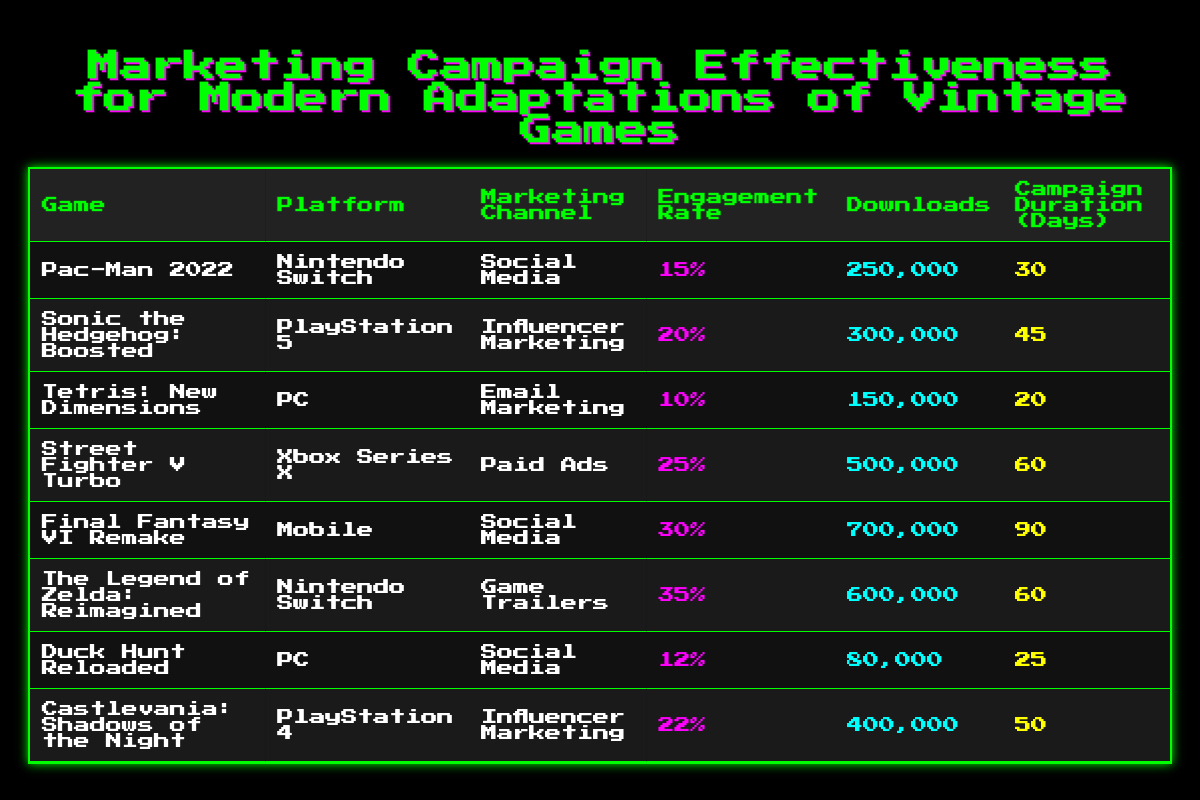What is the platform for "Sonic the Hedgehog: Boosted"? The platform is mentioned in the table directly under the "Platform" column corresponding to "Sonic the Hedgehog: Boosted". The entry shows "PlayStation 5".
Answer: PlayStation 5 Which game had the highest engagement rate? To find this, I look under the "Engagement Rate" column and compare the values. The highest value is 35%, associated with "The Legend of Zelda: Reimagined".
Answer: The Legend of Zelda: Reimagined What is the total number of downloads for games on the Nintendo Switch? I first identify the Nintendo Switch games: "Pac-Man 2022" and "The Legend of Zelda: Reimagined". Next, I sum their downloads: 250,000 + 600,000 = 850,000.
Answer: 850,000 Is the engagement rate for "Tetris: New Dimensions" greater than 15%? The engagement rate for "Tetris: New Dimensions" is 10%, which is lower than 15%. Therefore, the statement is false.
Answer: No How many days of campaign duration did "Final Fantasy VI Remake" have? The "Campaign Duration (Days)" column shows 90 days for "Final Fantasy VI Remake". I directly reference this value.
Answer: 90 days What is the difference in downloads between "Street Fighter V Turbo" and "Duck Hunt Reloaded"? I find the downloads: "Street Fighter V Turbo" has 500,000 downloads, and "Duck Hunt Reloaded" has 80,000 downloads. I calculate the difference: 500,000 - 80,000 = 420,000.
Answer: 420,000 Which marketing channel yielded the most downloads? I examine each game and its downloads, matching them with their respective marketing channels. "Final Fantasy VI Remake," with 700,000 downloads using Social Media, is the highest.
Answer: Social Media What percentage of the total downloads came from "Influencer Marketing"? I identify the total downloads for the two Influencer Marketing games: "Sonic the Hedgehog: Boosted" (300,000) and "Castlevania: Shadows of the Night" (400,000), giving a total of 700,000. The overall total downloads from all games is 2,310,000. Thus, the percentage is (700,000 / 2,310,000) * 100 ≈ 30.3%.
Answer: Approximately 30.3% 